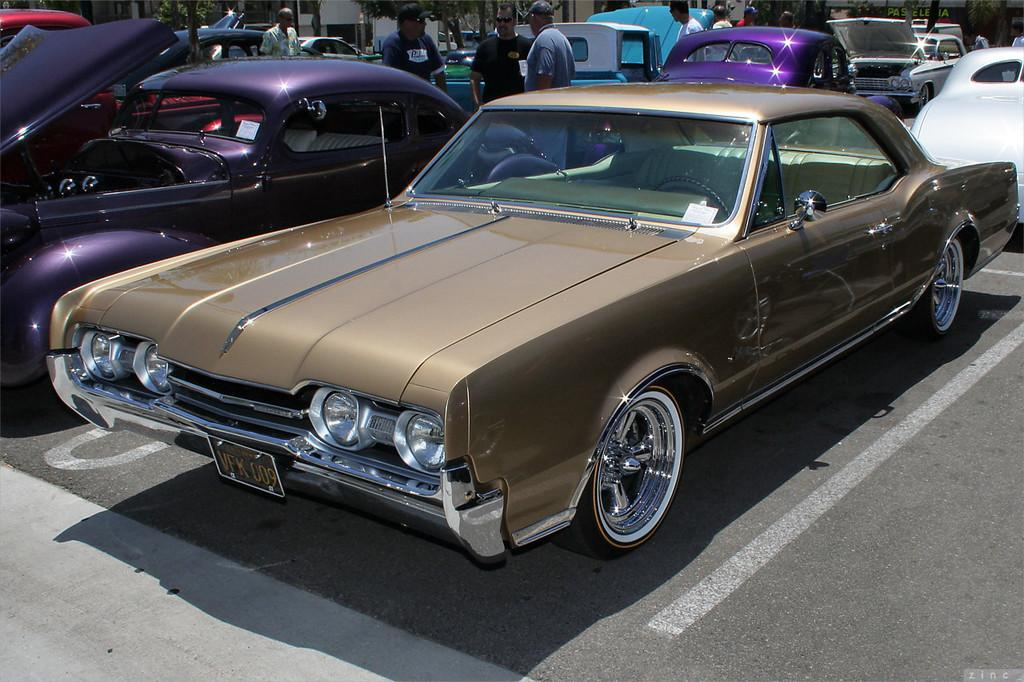What can be seen on the road in the image? There are cars on the road in the image. What is happening in the background of the image? In the background, there are persons standing, trees, buildings, a hoarding, and other unspecified objects. Can you describe the objects in the background? The background features trees, buildings, a hoarding, and other unspecified objects. What type of milk is being advertised on the hoarding in the image? There is no milk or advertisement present on the hoarding in the image. How many pins are holding the hoarding in place in the image? There are no pins visible in the image, and the hoarding's method of attachment is not mentioned. 